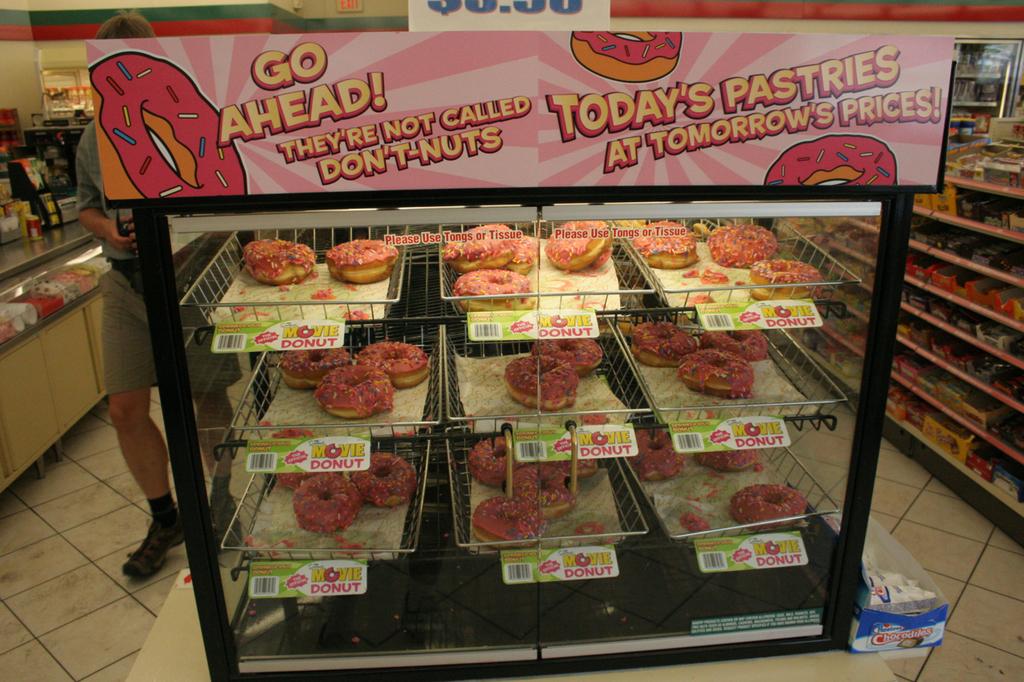What is being sold here?
Provide a succinct answer. Answering does not require reading text in the image. When are the prices from?
Your answer should be compact. Tomorrow. 